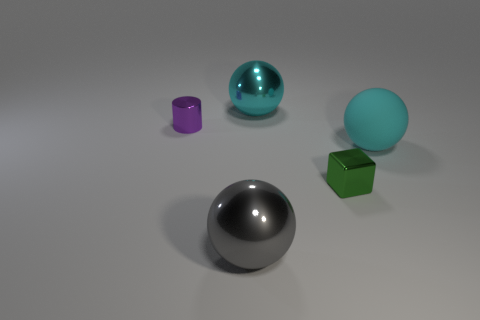Add 1 green rubber cylinders. How many objects exist? 6 Subtract all balls. How many objects are left? 2 Add 2 purple cylinders. How many purple cylinders are left? 3 Add 5 big gray spheres. How many big gray spheres exist? 6 Subtract 0 red cylinders. How many objects are left? 5 Subtract all big gray metallic balls. Subtract all shiny objects. How many objects are left? 0 